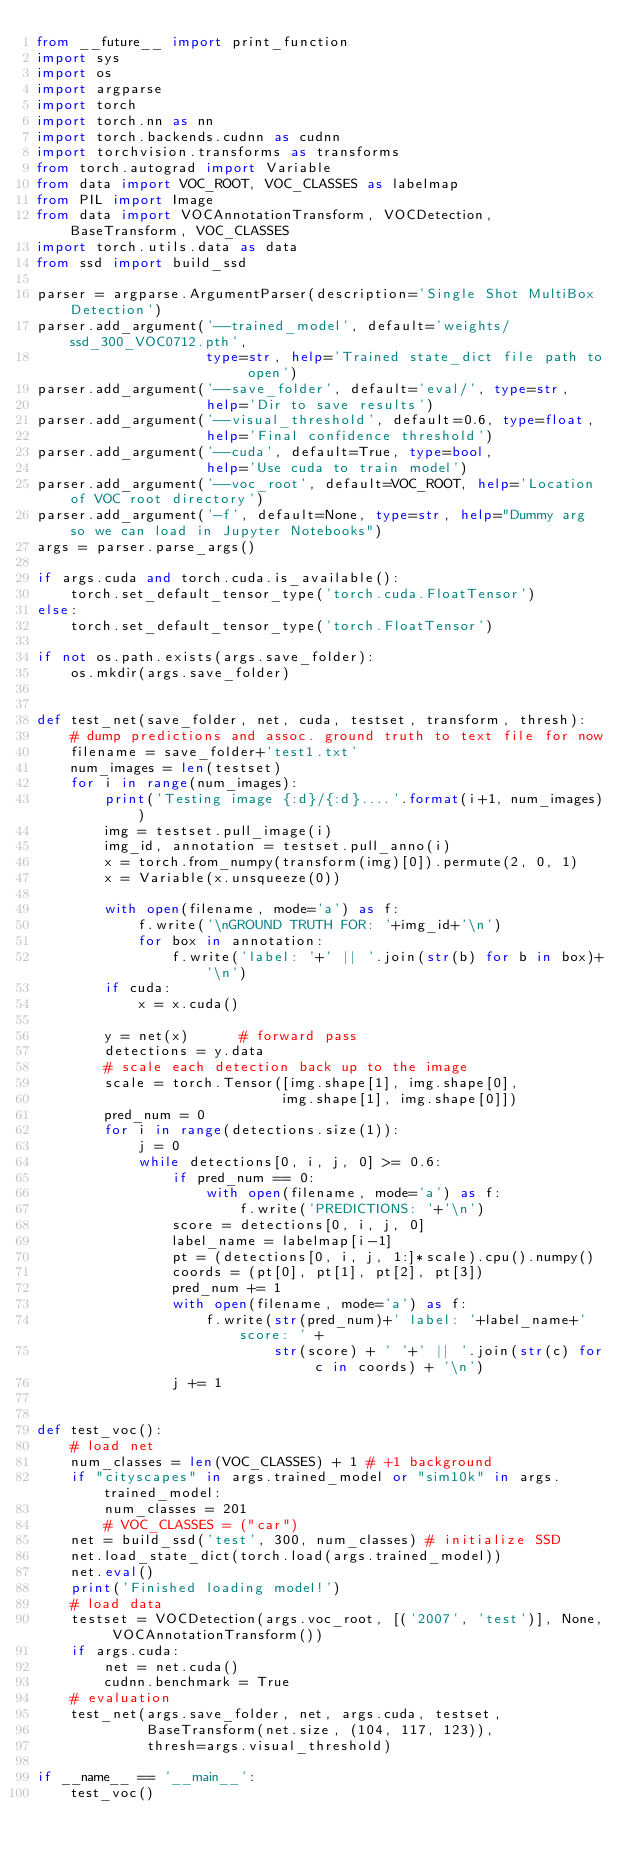<code> <loc_0><loc_0><loc_500><loc_500><_Python_>from __future__ import print_function
import sys
import os
import argparse
import torch
import torch.nn as nn
import torch.backends.cudnn as cudnn
import torchvision.transforms as transforms
from torch.autograd import Variable
from data import VOC_ROOT, VOC_CLASSES as labelmap
from PIL import Image
from data import VOCAnnotationTransform, VOCDetection, BaseTransform, VOC_CLASSES
import torch.utils.data as data
from ssd import build_ssd

parser = argparse.ArgumentParser(description='Single Shot MultiBox Detection')
parser.add_argument('--trained_model', default='weights/ssd_300_VOC0712.pth',
                    type=str, help='Trained state_dict file path to open')
parser.add_argument('--save_folder', default='eval/', type=str,
                    help='Dir to save results')
parser.add_argument('--visual_threshold', default=0.6, type=float,
                    help='Final confidence threshold')
parser.add_argument('--cuda', default=True, type=bool,
                    help='Use cuda to train model')
parser.add_argument('--voc_root', default=VOC_ROOT, help='Location of VOC root directory')
parser.add_argument('-f', default=None, type=str, help="Dummy arg so we can load in Jupyter Notebooks")
args = parser.parse_args()

if args.cuda and torch.cuda.is_available():
    torch.set_default_tensor_type('torch.cuda.FloatTensor')
else:
    torch.set_default_tensor_type('torch.FloatTensor')

if not os.path.exists(args.save_folder):
    os.mkdir(args.save_folder)


def test_net(save_folder, net, cuda, testset, transform, thresh):
    # dump predictions and assoc. ground truth to text file for now
    filename = save_folder+'test1.txt'
    num_images = len(testset)
    for i in range(num_images):
        print('Testing image {:d}/{:d}....'.format(i+1, num_images))
        img = testset.pull_image(i)
        img_id, annotation = testset.pull_anno(i)
        x = torch.from_numpy(transform(img)[0]).permute(2, 0, 1)
        x = Variable(x.unsqueeze(0))

        with open(filename, mode='a') as f:
            f.write('\nGROUND TRUTH FOR: '+img_id+'\n')
            for box in annotation:
                f.write('label: '+' || '.join(str(b) for b in box)+'\n')
        if cuda:
            x = x.cuda()

        y = net(x)      # forward pass
        detections = y.data
        # scale each detection back up to the image
        scale = torch.Tensor([img.shape[1], img.shape[0],
                             img.shape[1], img.shape[0]])
        pred_num = 0
        for i in range(detections.size(1)):
            j = 0
            while detections[0, i, j, 0] >= 0.6:
                if pred_num == 0:
                    with open(filename, mode='a') as f:
                        f.write('PREDICTIONS: '+'\n')
                score = detections[0, i, j, 0]
                label_name = labelmap[i-1]
                pt = (detections[0, i, j, 1:]*scale).cpu().numpy()
                coords = (pt[0], pt[1], pt[2], pt[3])
                pred_num += 1
                with open(filename, mode='a') as f:
                    f.write(str(pred_num)+' label: '+label_name+' score: ' +
                            str(score) + ' '+' || '.join(str(c) for c in coords) + '\n')
                j += 1


def test_voc():
    # load net
    num_classes = len(VOC_CLASSES) + 1 # +1 background
    if "cityscapes" in args.trained_model or "sim10k" in args.trained_model:
        num_classes = 201
        # VOC_CLASSES = ("car")
    net = build_ssd('test', 300, num_classes) # initialize SSD
    net.load_state_dict(torch.load(args.trained_model))
    net.eval()
    print('Finished loading model!')
    # load data
    testset = VOCDetection(args.voc_root, [('2007', 'test')], None, VOCAnnotationTransform())
    if args.cuda:
        net = net.cuda()
        cudnn.benchmark = True
    # evaluation
    test_net(args.save_folder, net, args.cuda, testset,
             BaseTransform(net.size, (104, 117, 123)),
             thresh=args.visual_threshold)

if __name__ == '__main__':
    test_voc()
</code> 